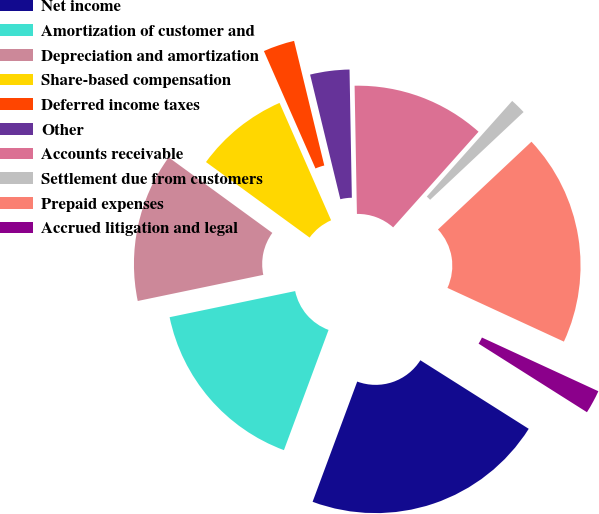Convert chart. <chart><loc_0><loc_0><loc_500><loc_500><pie_chart><fcel>Net income<fcel>Amortization of customer and<fcel>Depreciation and amortization<fcel>Share-based compensation<fcel>Deferred income taxes<fcel>Other<fcel>Accounts receivable<fcel>Settlement due from customers<fcel>Prepaid expenses<fcel>Accrued litigation and legal<nl><fcel>21.68%<fcel>16.08%<fcel>13.29%<fcel>8.39%<fcel>2.8%<fcel>3.5%<fcel>11.89%<fcel>1.4%<fcel>18.88%<fcel>2.1%<nl></chart> 